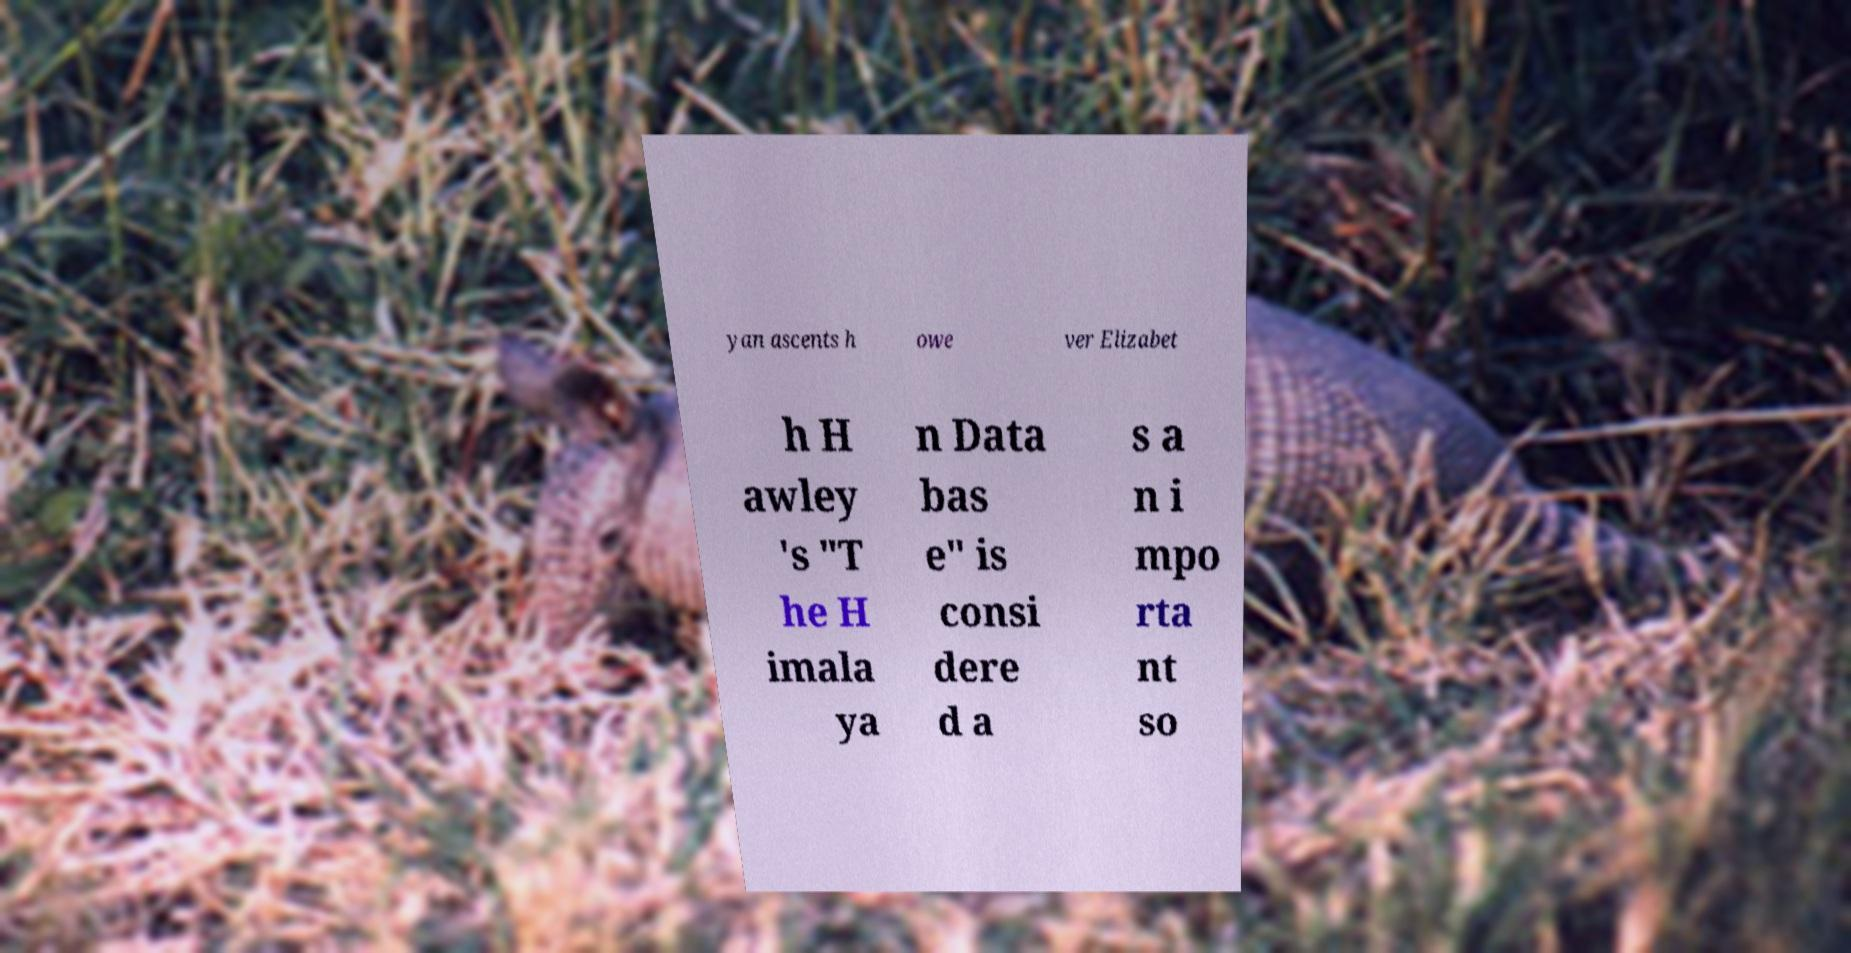Please identify and transcribe the text found in this image. yan ascents h owe ver Elizabet h H awley 's "T he H imala ya n Data bas e" is consi dere d a s a n i mpo rta nt so 